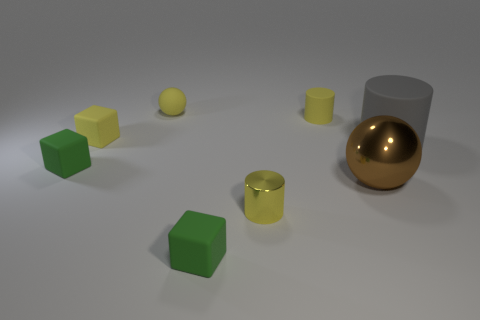Does the small sphere have the same color as the tiny shiny thing?
Your answer should be very brief. Yes. How many yellow cylinders have the same size as the brown shiny object?
Offer a very short reply. 0. There is a ball that is the same color as the tiny rubber cylinder; what size is it?
Offer a terse response. Small. There is a thing that is in front of the large brown sphere and to the left of the tiny metal cylinder; how big is it?
Offer a terse response. Small. How many yellow cylinders are behind the large shiny sphere that is in front of the tiny green matte object on the left side of the yellow rubber ball?
Offer a very short reply. 1. Are there any tiny rubber things that have the same color as the small shiny thing?
Make the answer very short. Yes. There is a ball that is the same size as the yellow shiny cylinder; what color is it?
Offer a very short reply. Yellow. There is a small green object that is to the left of the small green matte block in front of the small yellow object that is in front of the large rubber thing; what shape is it?
Ensure brevity in your answer.  Cube. How many objects are behind the cube that is to the right of the yellow sphere?
Give a very brief answer. 7. Do the small rubber object in front of the big shiny thing and the large thing left of the gray matte thing have the same shape?
Give a very brief answer. No. 